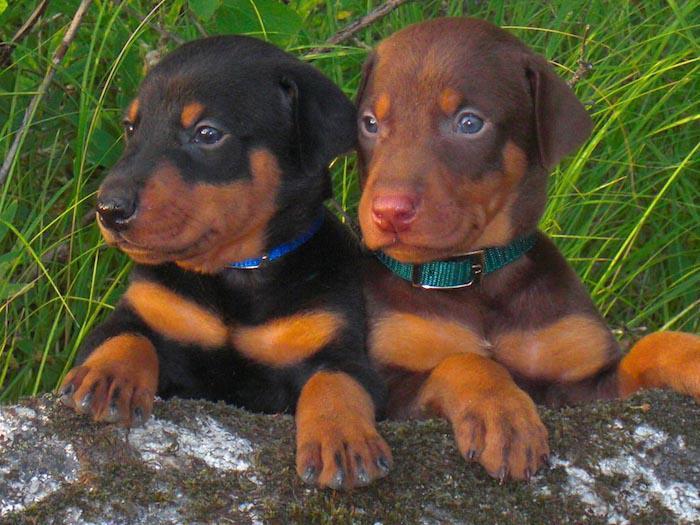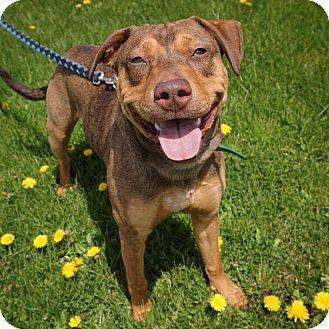The first image is the image on the left, the second image is the image on the right. For the images shown, is this caption "Each image contains a pair of animals, but one image features puppies and the other features adult dogs." true? Answer yes or no. No. The first image is the image on the left, the second image is the image on the right. Assess this claim about the two images: "At least one dog is sitting on a tile floor.". Correct or not? Answer yes or no. No. 